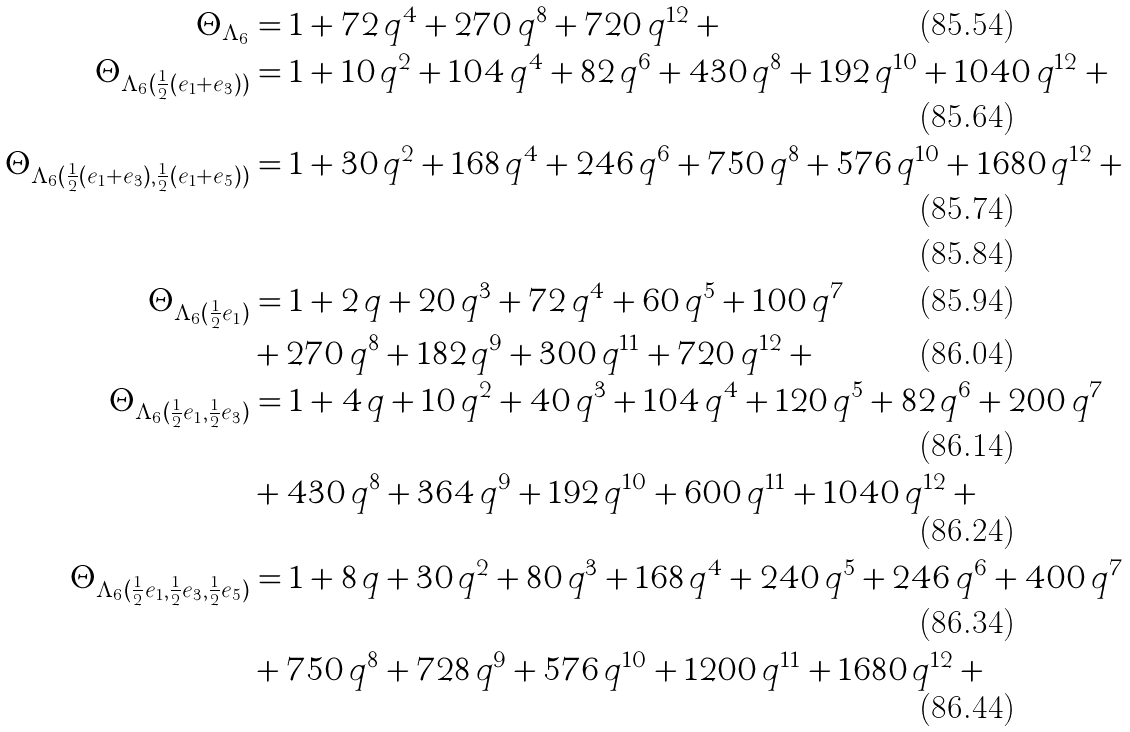<formula> <loc_0><loc_0><loc_500><loc_500>\Theta _ { \Lambda _ { 6 } } & = 1 + 7 2 \, q ^ { 4 } + 2 7 0 \, q ^ { 8 } + 7 2 0 \, q ^ { 1 2 } + \cdots \\ \Theta _ { \Lambda _ { 6 } ( \frac { 1 } { 2 } ( e _ { 1 } + e _ { 3 } ) ) } & = 1 + 1 0 \, q ^ { 2 } + 1 0 4 \, q ^ { 4 } + 8 2 \, q ^ { 6 } + 4 3 0 \, q ^ { 8 } + 1 9 2 \, q ^ { 1 0 } + 1 0 4 0 \, q ^ { 1 2 } + \cdots \\ \Theta _ { \Lambda _ { 6 } ( \frac { 1 } { 2 } ( e _ { 1 } + e _ { 3 } ) , \frac { 1 } { 2 } ( e _ { 1 } + e _ { 5 } ) ) } & = 1 + 3 0 \, q ^ { 2 } + 1 6 8 \, q ^ { 4 } + 2 4 6 \, q ^ { 6 } + 7 5 0 \, q ^ { 8 } + 5 7 6 \, q ^ { 1 0 } + 1 6 8 0 \, q ^ { 1 2 } + \cdots \\ \quad \\ \Theta _ { \Lambda _ { 6 } ( \frac { 1 } { 2 } e _ { 1 } ) } & = 1 + 2 \, q + 2 0 \, q ^ { 3 } + 7 2 \, q ^ { 4 } + 6 0 \, q ^ { 5 } + 1 0 0 \, q ^ { 7 } \\ & + 2 7 0 \, q ^ { 8 } + 1 8 2 \, q ^ { 9 } + 3 0 0 \, q ^ { 1 1 } + 7 2 0 \, q ^ { 1 2 } + \cdots \\ \Theta _ { \Lambda _ { 6 } ( \frac { 1 } { 2 } e _ { 1 } , \frac { 1 } { 2 } e _ { 3 } ) } & = 1 + 4 \, q + 1 0 \, q ^ { 2 } + 4 0 \, q ^ { 3 } + 1 0 4 \, q ^ { 4 } + 1 2 0 \, q ^ { 5 } + 8 2 \, q ^ { 6 } + 2 0 0 \, q ^ { 7 } \\ & + 4 3 0 \, q ^ { 8 } + 3 6 4 \, q ^ { 9 } + 1 9 2 \, q ^ { 1 0 } + 6 0 0 \, q ^ { 1 1 } + 1 0 4 0 \, q ^ { 1 2 } + \cdots \\ \Theta _ { \Lambda _ { 6 } ( \frac { 1 } { 2 } e _ { 1 } , \frac { 1 } { 2 } e _ { 3 } , \frac { 1 } { 2 } e _ { 5 } ) } & = 1 + 8 \, q + 3 0 \, q ^ { 2 } + 8 0 \, q ^ { 3 } + 1 6 8 \, q ^ { 4 } + 2 4 0 \, q ^ { 5 } + 2 4 6 \, q ^ { 6 } + 4 0 0 \, q ^ { 7 } \\ & + 7 5 0 \, q ^ { 8 } + 7 2 8 \, q ^ { 9 } + 5 7 6 \, q ^ { 1 0 } + 1 2 0 0 \, q ^ { 1 1 } + 1 6 8 0 \, q ^ { 1 2 } + \cdots</formula> 